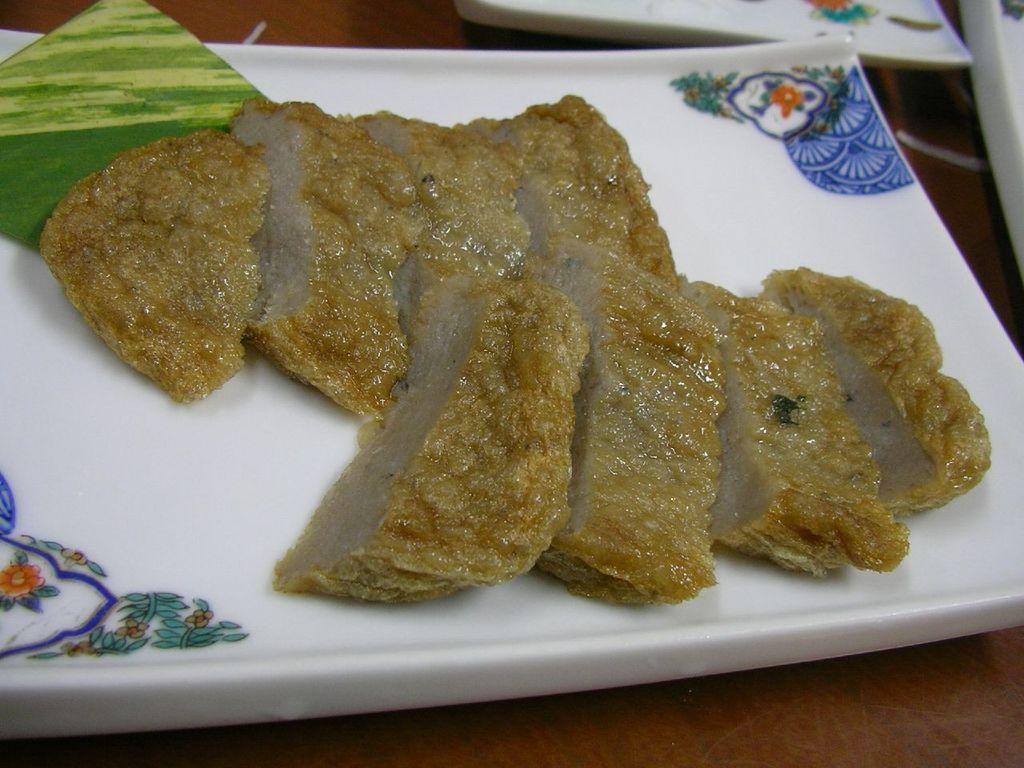In one or two sentences, can you explain what this image depicts? In this image I can see the plate with food. The food is in brown color and the plate is in white color. To the side I can see few more plates. These are on the table. 